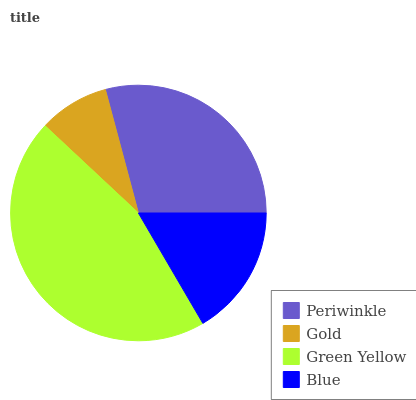Is Gold the minimum?
Answer yes or no. Yes. Is Green Yellow the maximum?
Answer yes or no. Yes. Is Green Yellow the minimum?
Answer yes or no. No. Is Gold the maximum?
Answer yes or no. No. Is Green Yellow greater than Gold?
Answer yes or no. Yes. Is Gold less than Green Yellow?
Answer yes or no. Yes. Is Gold greater than Green Yellow?
Answer yes or no. No. Is Green Yellow less than Gold?
Answer yes or no. No. Is Periwinkle the high median?
Answer yes or no. Yes. Is Blue the low median?
Answer yes or no. Yes. Is Gold the high median?
Answer yes or no. No. Is Gold the low median?
Answer yes or no. No. 